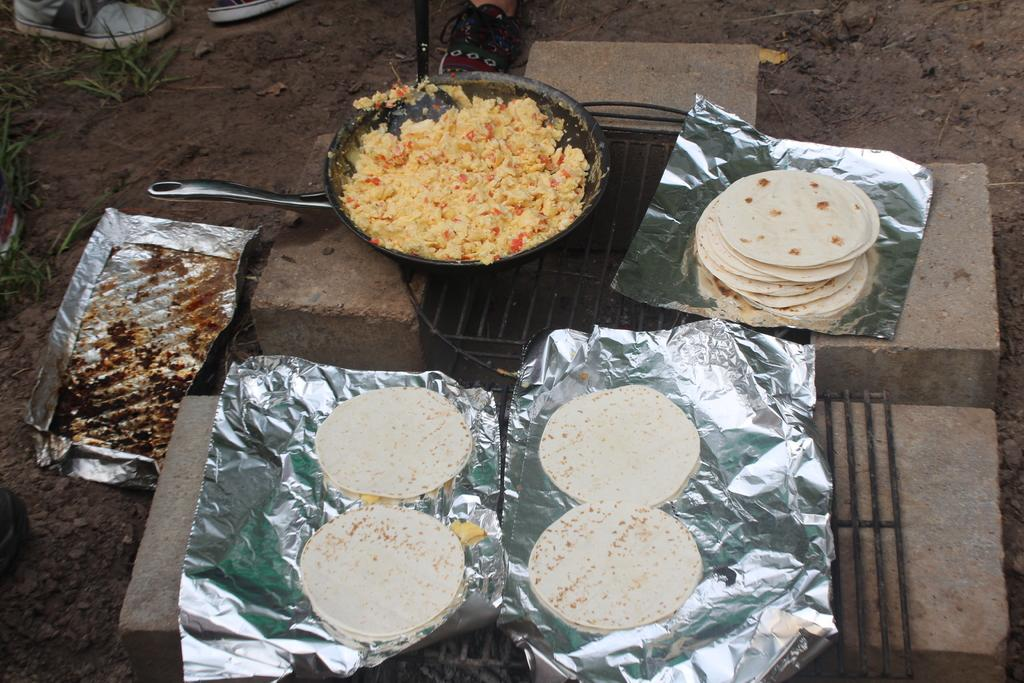What is the main subject of the image? The main subject of the image is food items arranged on bricks. Can you describe the food items in the image? There is a pan with food in the image. Are there any other objects or people visible in the image? The shoes of two people are visible at the top of the image. What type of picture is hanging on the wall in the image? There is no picture hanging on the wall in the image; the focus is on the food items arranged on bricks and the pan with food. How can someone join the two people whose shoes are visible in the image? The image does not provide information about how someone can join the two people, as it only shows their shoes and not their location or activity. 